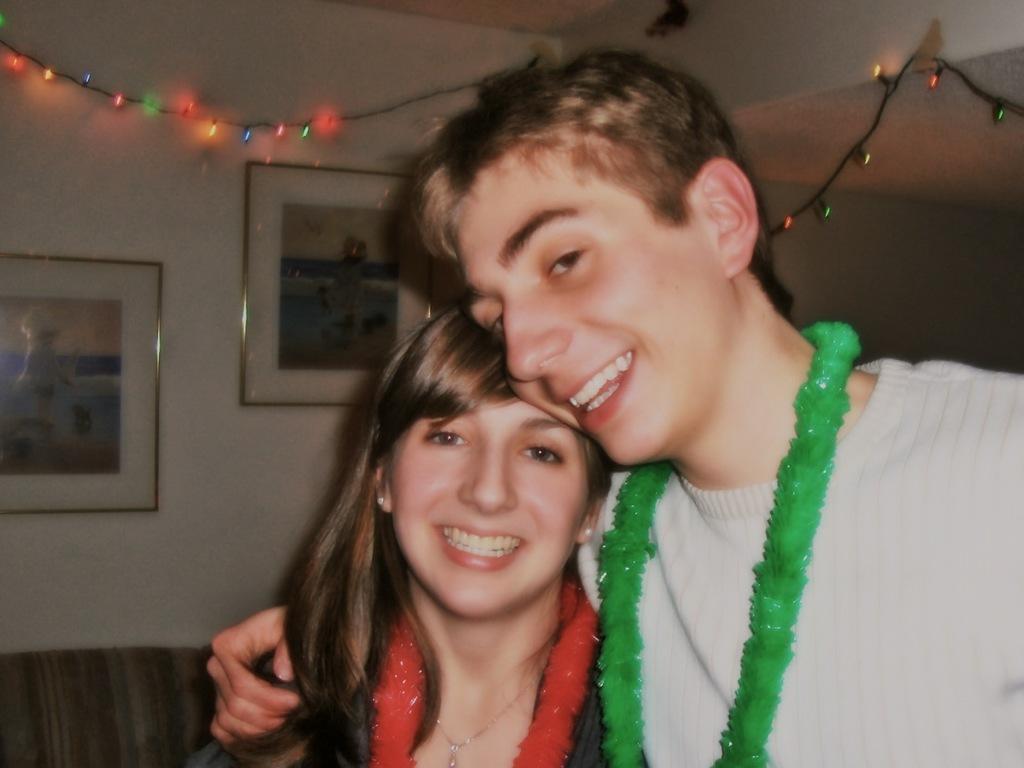Please provide a concise description of this image. In this picture we can see a man and a woman here, in the background we can see serial lights, there is a wall where, there are two photo frames on the wall. 